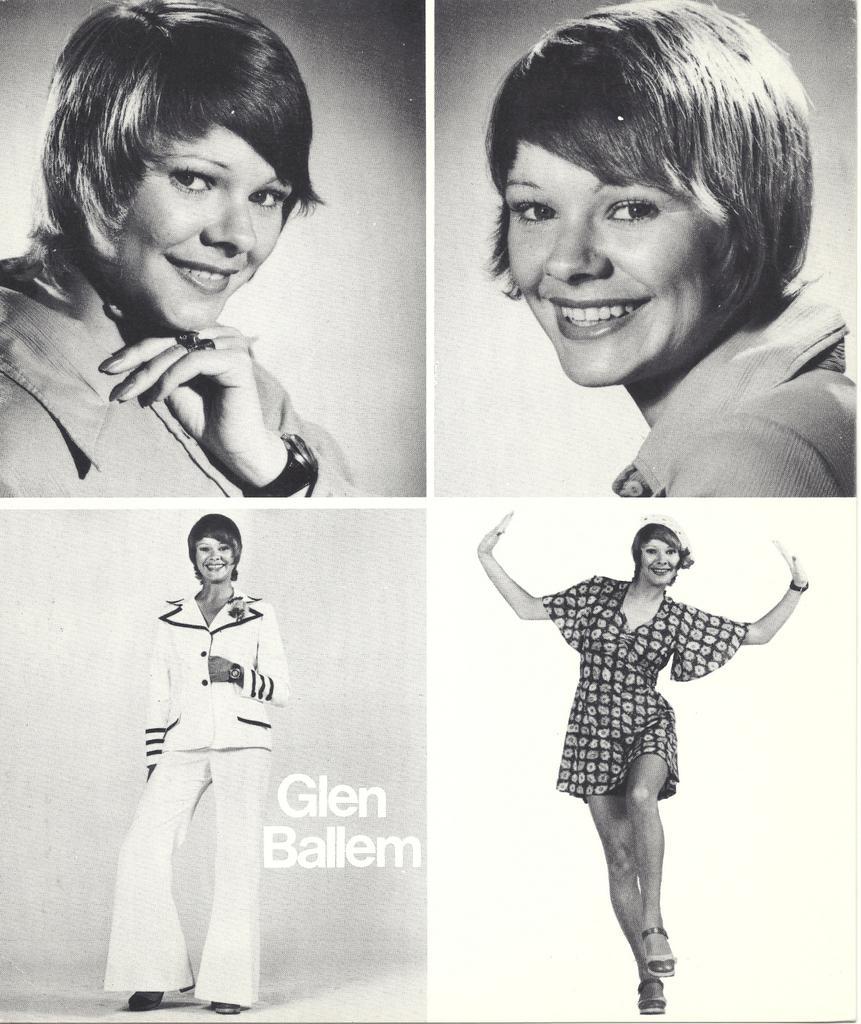Please provide a concise description of this image. In this picture I can see a woman smiling on the left side, on the right side a woman is jumping, it is a photo collage. 